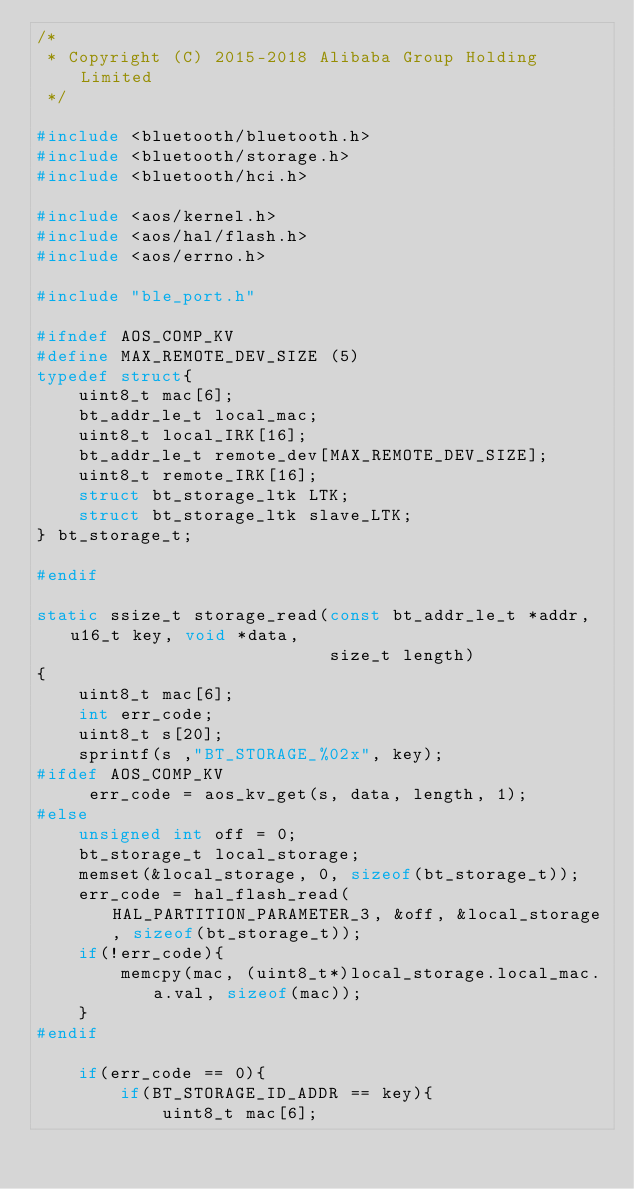<code> <loc_0><loc_0><loc_500><loc_500><_C_>/*
 * Copyright (C) 2015-2018 Alibaba Group Holding Limited
 */

#include <bluetooth/bluetooth.h>
#include <bluetooth/storage.h>
#include <bluetooth/hci.h>

#include <aos/kernel.h>
#include <aos/hal/flash.h>
#include <aos/errno.h>

#include "ble_port.h"

#ifndef AOS_COMP_KV
#define MAX_REMOTE_DEV_SIZE (5)
typedef struct{
    uint8_t mac[6];
    bt_addr_le_t local_mac;
    uint8_t local_IRK[16];
    bt_addr_le_t remote_dev[MAX_REMOTE_DEV_SIZE];
    uint8_t remote_IRK[16];
    struct bt_storage_ltk LTK;
    struct bt_storage_ltk slave_LTK;
} bt_storage_t;

#endif

static ssize_t storage_read(const bt_addr_le_t *addr, u16_t key, void *data,
                            size_t length)
{
    uint8_t mac[6];
    int err_code;
    uint8_t s[20];
    sprintf(s ,"BT_STORAGE_%02x", key);
#ifdef AOS_COMP_KV
     err_code = aos_kv_get(s, data, length, 1);
#else
    unsigned int off = 0;
    bt_storage_t local_storage;
    memset(&local_storage, 0, sizeof(bt_storage_t));
    err_code = hal_flash_read(HAL_PARTITION_PARAMETER_3, &off, &local_storage, sizeof(bt_storage_t));
    if(!err_code){
        memcpy(mac, (uint8_t*)local_storage.local_mac.a.val, sizeof(mac));
    }
#endif

    if(err_code == 0){
        if(BT_STORAGE_ID_ADDR == key){
            uint8_t mac[6];</code> 